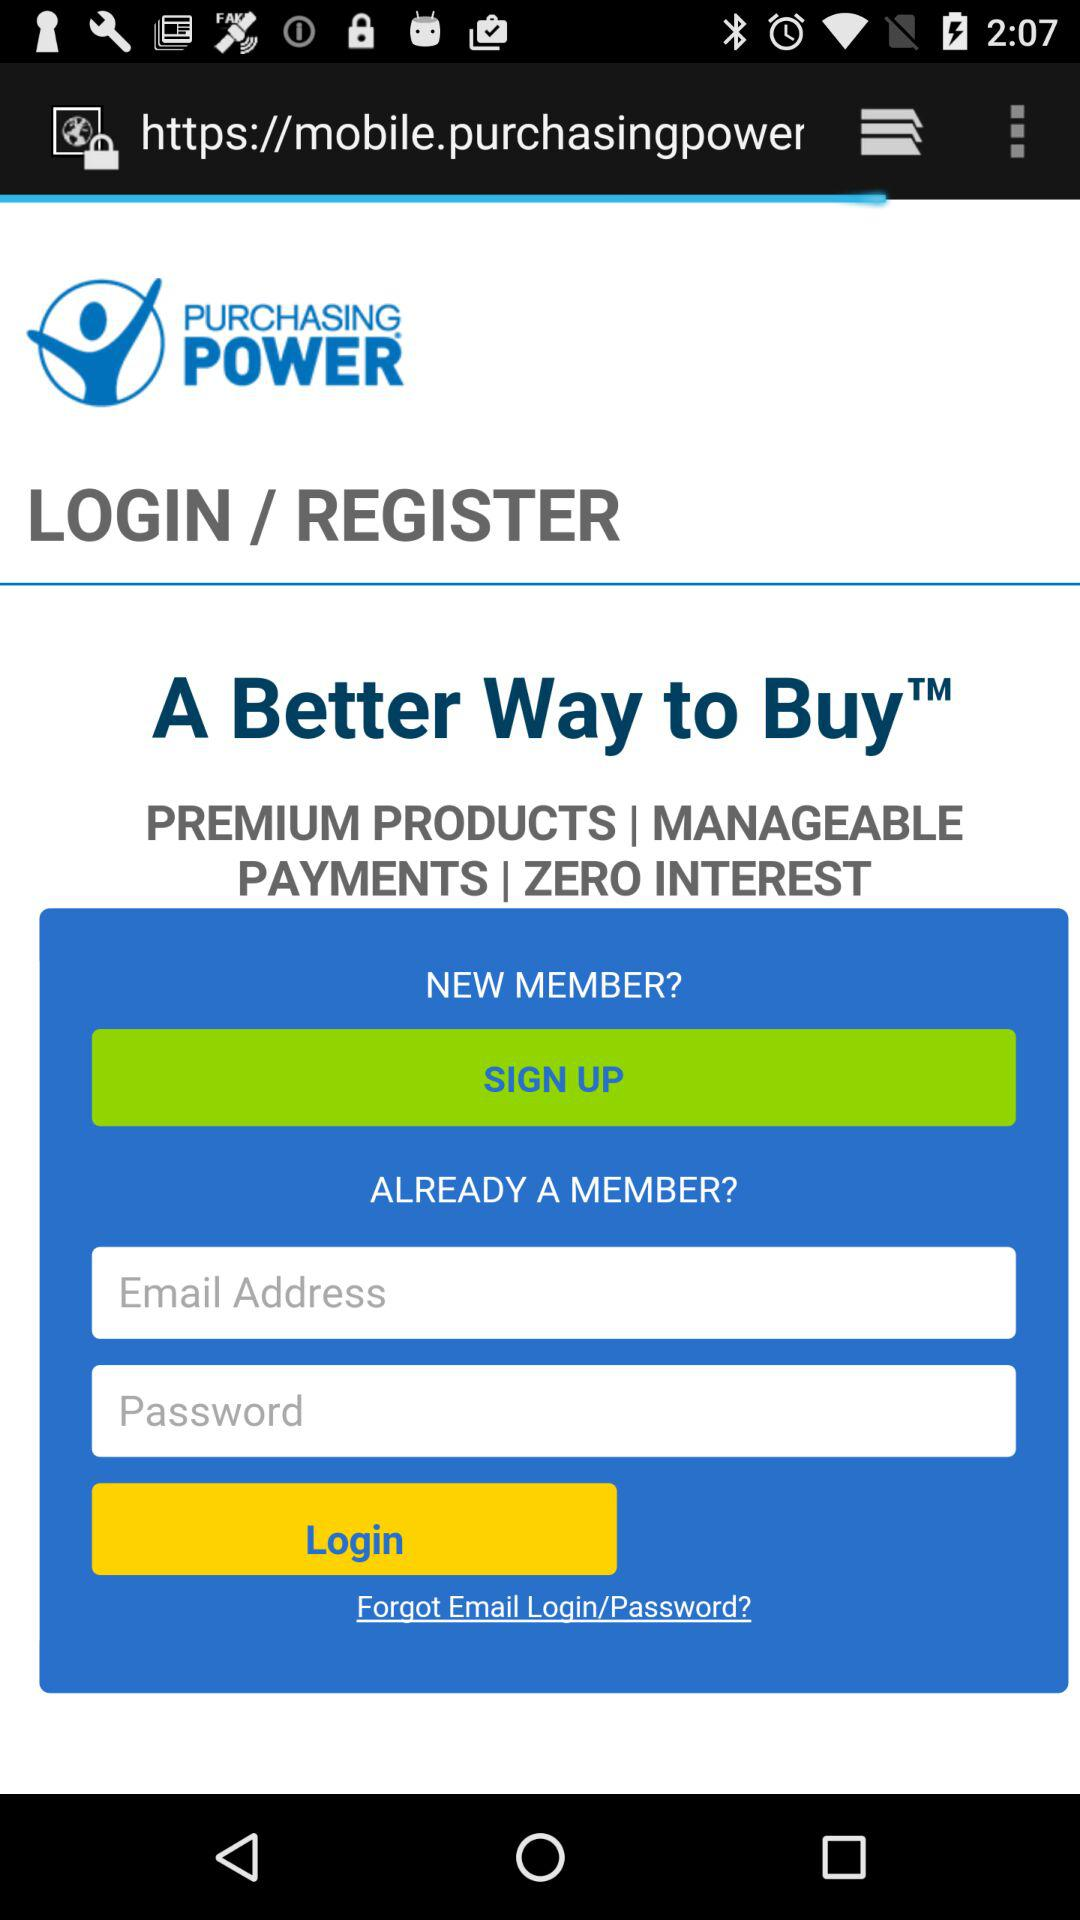How many text inputs are there for the login form?
Answer the question using a single word or phrase. 2 